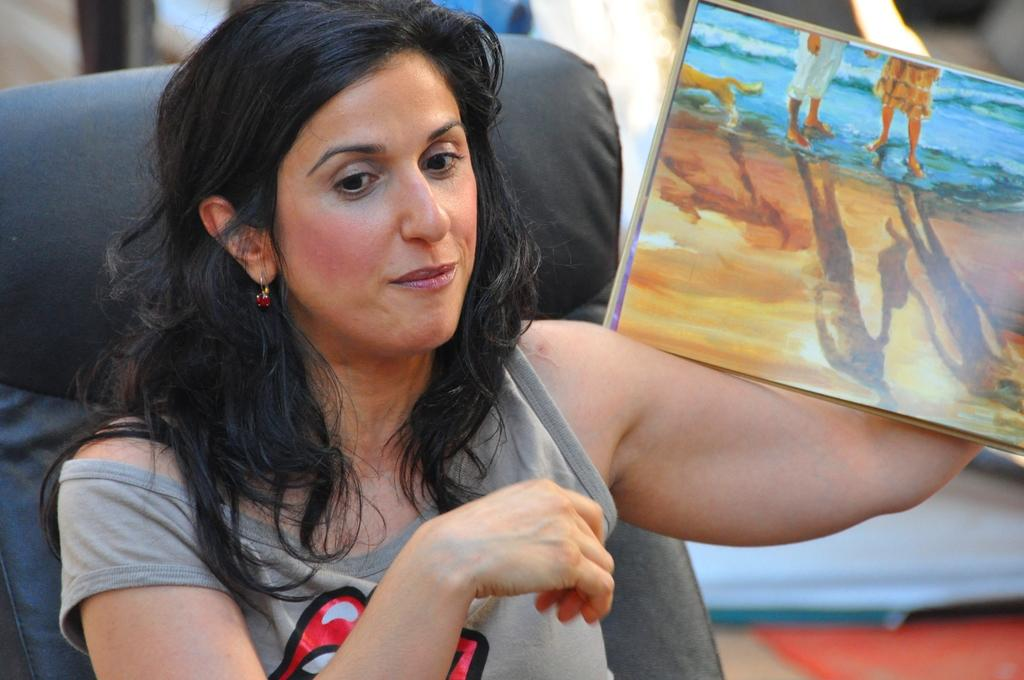Who is the main subject in the image? There is a woman in the image. What is the woman doing in the image? The woman is sitting on a chair. What is the woman holding in her hand? The woman is holding a painting in her hand. Can you describe the background of the image? The background of the image is blurred. What type of loaf is the woman holding in her hand? The woman is not holding a loaf in her hand; she is holding a painting. 